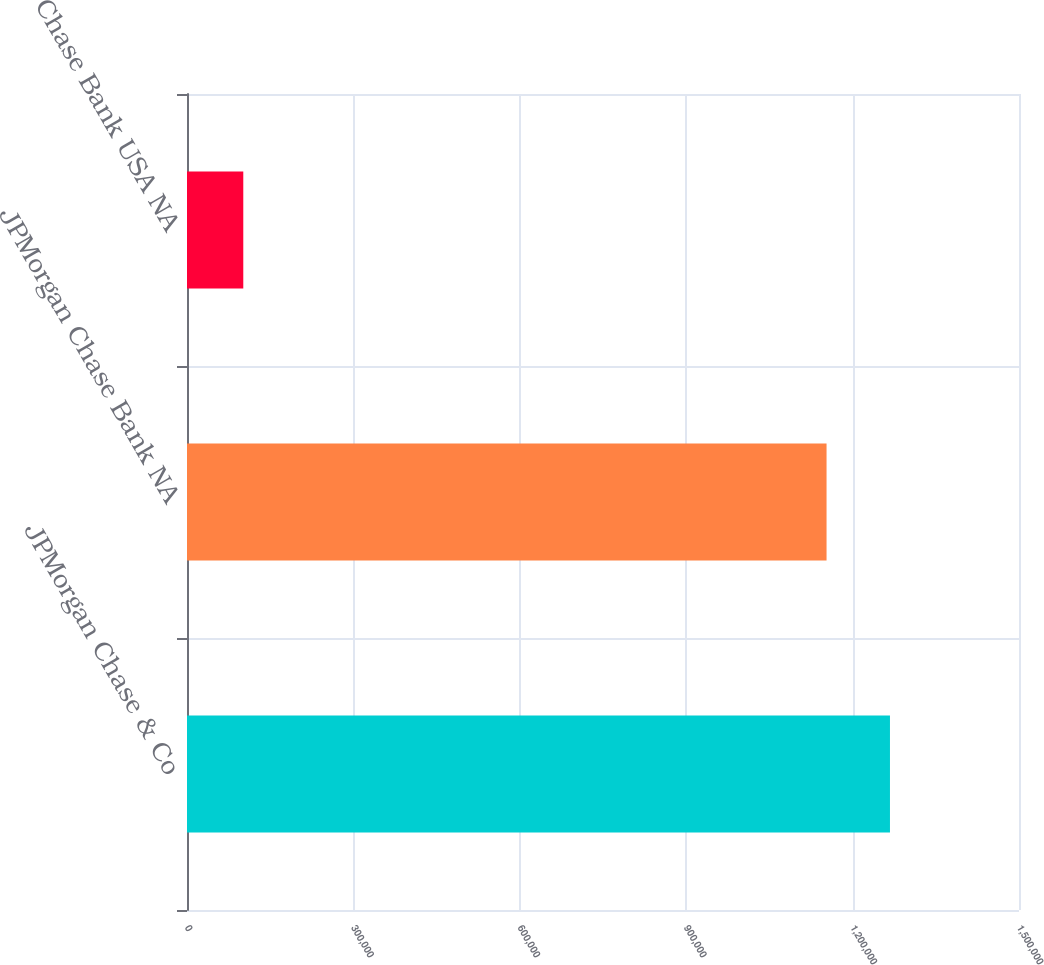<chart> <loc_0><loc_0><loc_500><loc_500><bar_chart><fcel>JPMorgan Chase & Co<fcel>JPMorgan Chase Bank NA<fcel>Chase Bank USA NA<nl><fcel>1.26736e+06<fcel>1.15304e+06<fcel>101472<nl></chart> 